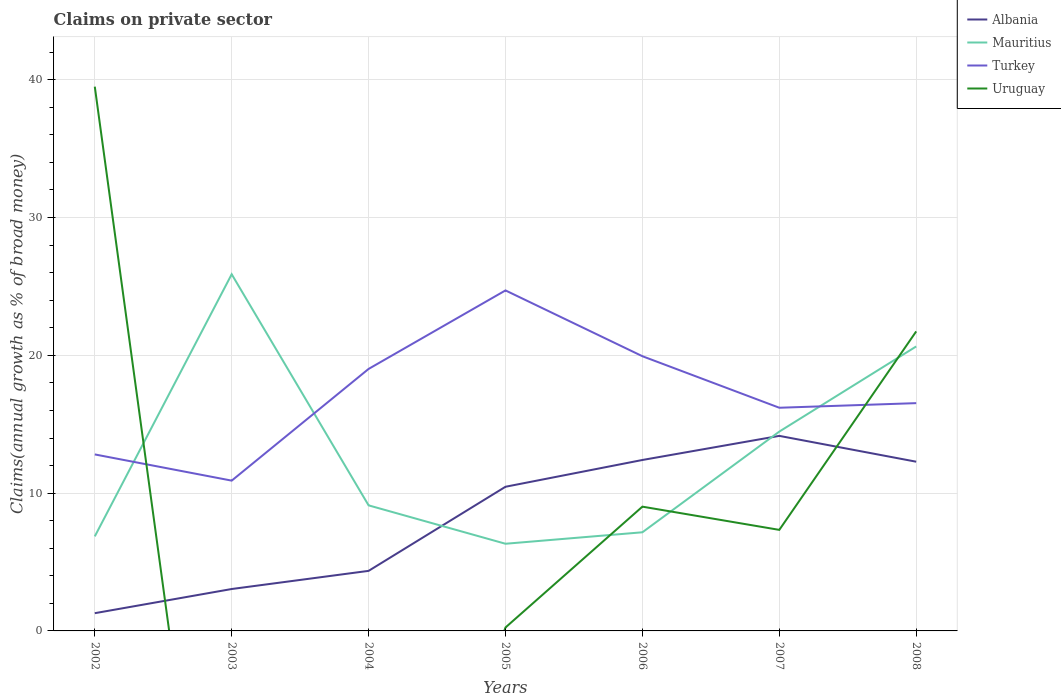How many different coloured lines are there?
Keep it short and to the point. 4. Does the line corresponding to Turkey intersect with the line corresponding to Mauritius?
Your response must be concise. Yes. Across all years, what is the maximum percentage of broad money claimed on private sector in Albania?
Your response must be concise. 1.29. What is the total percentage of broad money claimed on private sector in Mauritius in the graph?
Your response must be concise. -8.14. What is the difference between the highest and the second highest percentage of broad money claimed on private sector in Uruguay?
Keep it short and to the point. 39.5. What is the difference between the highest and the lowest percentage of broad money claimed on private sector in Uruguay?
Provide a short and direct response. 2. Is the percentage of broad money claimed on private sector in Albania strictly greater than the percentage of broad money claimed on private sector in Mauritius over the years?
Make the answer very short. No. Are the values on the major ticks of Y-axis written in scientific E-notation?
Offer a very short reply. No. Does the graph contain any zero values?
Make the answer very short. Yes. How many legend labels are there?
Your response must be concise. 4. What is the title of the graph?
Your answer should be very brief. Claims on private sector. Does "Curacao" appear as one of the legend labels in the graph?
Ensure brevity in your answer.  No. What is the label or title of the Y-axis?
Offer a very short reply. Claims(annual growth as % of broad money). What is the Claims(annual growth as % of broad money) in Albania in 2002?
Ensure brevity in your answer.  1.29. What is the Claims(annual growth as % of broad money) of Mauritius in 2002?
Provide a succinct answer. 6.86. What is the Claims(annual growth as % of broad money) of Turkey in 2002?
Your response must be concise. 12.81. What is the Claims(annual growth as % of broad money) of Uruguay in 2002?
Your answer should be very brief. 39.5. What is the Claims(annual growth as % of broad money) of Albania in 2003?
Your response must be concise. 3.04. What is the Claims(annual growth as % of broad money) of Mauritius in 2003?
Ensure brevity in your answer.  25.88. What is the Claims(annual growth as % of broad money) in Turkey in 2003?
Your response must be concise. 10.91. What is the Claims(annual growth as % of broad money) of Albania in 2004?
Provide a short and direct response. 4.36. What is the Claims(annual growth as % of broad money) of Mauritius in 2004?
Give a very brief answer. 9.11. What is the Claims(annual growth as % of broad money) in Turkey in 2004?
Ensure brevity in your answer.  19.01. What is the Claims(annual growth as % of broad money) of Uruguay in 2004?
Your answer should be very brief. 0. What is the Claims(annual growth as % of broad money) in Albania in 2005?
Your answer should be very brief. 10.46. What is the Claims(annual growth as % of broad money) of Mauritius in 2005?
Keep it short and to the point. 6.33. What is the Claims(annual growth as % of broad money) of Turkey in 2005?
Keep it short and to the point. 24.71. What is the Claims(annual growth as % of broad money) in Uruguay in 2005?
Give a very brief answer. 0.25. What is the Claims(annual growth as % of broad money) of Albania in 2006?
Your answer should be very brief. 12.41. What is the Claims(annual growth as % of broad money) of Mauritius in 2006?
Offer a terse response. 7.16. What is the Claims(annual growth as % of broad money) of Turkey in 2006?
Your answer should be very brief. 19.94. What is the Claims(annual growth as % of broad money) of Uruguay in 2006?
Make the answer very short. 9.02. What is the Claims(annual growth as % of broad money) in Albania in 2007?
Offer a terse response. 14.15. What is the Claims(annual growth as % of broad money) of Mauritius in 2007?
Offer a very short reply. 14.47. What is the Claims(annual growth as % of broad money) of Turkey in 2007?
Keep it short and to the point. 16.2. What is the Claims(annual growth as % of broad money) of Uruguay in 2007?
Offer a very short reply. 7.33. What is the Claims(annual growth as % of broad money) in Albania in 2008?
Provide a succinct answer. 12.28. What is the Claims(annual growth as % of broad money) of Mauritius in 2008?
Provide a short and direct response. 20.65. What is the Claims(annual growth as % of broad money) in Turkey in 2008?
Ensure brevity in your answer.  16.53. What is the Claims(annual growth as % of broad money) in Uruguay in 2008?
Offer a terse response. 21.74. Across all years, what is the maximum Claims(annual growth as % of broad money) of Albania?
Provide a short and direct response. 14.15. Across all years, what is the maximum Claims(annual growth as % of broad money) of Mauritius?
Offer a very short reply. 25.88. Across all years, what is the maximum Claims(annual growth as % of broad money) of Turkey?
Offer a very short reply. 24.71. Across all years, what is the maximum Claims(annual growth as % of broad money) of Uruguay?
Your response must be concise. 39.5. Across all years, what is the minimum Claims(annual growth as % of broad money) in Albania?
Your response must be concise. 1.29. Across all years, what is the minimum Claims(annual growth as % of broad money) in Mauritius?
Your answer should be very brief. 6.33. Across all years, what is the minimum Claims(annual growth as % of broad money) of Turkey?
Keep it short and to the point. 10.91. What is the total Claims(annual growth as % of broad money) in Albania in the graph?
Offer a terse response. 57.99. What is the total Claims(annual growth as % of broad money) in Mauritius in the graph?
Give a very brief answer. 90.45. What is the total Claims(annual growth as % of broad money) of Turkey in the graph?
Ensure brevity in your answer.  120.1. What is the total Claims(annual growth as % of broad money) of Uruguay in the graph?
Make the answer very short. 77.84. What is the difference between the Claims(annual growth as % of broad money) of Albania in 2002 and that in 2003?
Provide a short and direct response. -1.75. What is the difference between the Claims(annual growth as % of broad money) in Mauritius in 2002 and that in 2003?
Provide a succinct answer. -19.02. What is the difference between the Claims(annual growth as % of broad money) of Turkey in 2002 and that in 2003?
Provide a succinct answer. 1.9. What is the difference between the Claims(annual growth as % of broad money) in Albania in 2002 and that in 2004?
Provide a short and direct response. -3.07. What is the difference between the Claims(annual growth as % of broad money) in Mauritius in 2002 and that in 2004?
Your answer should be very brief. -2.25. What is the difference between the Claims(annual growth as % of broad money) in Turkey in 2002 and that in 2004?
Your response must be concise. -6.2. What is the difference between the Claims(annual growth as % of broad money) in Albania in 2002 and that in 2005?
Provide a succinct answer. -9.18. What is the difference between the Claims(annual growth as % of broad money) of Mauritius in 2002 and that in 2005?
Make the answer very short. 0.53. What is the difference between the Claims(annual growth as % of broad money) in Turkey in 2002 and that in 2005?
Give a very brief answer. -11.9. What is the difference between the Claims(annual growth as % of broad money) in Uruguay in 2002 and that in 2005?
Ensure brevity in your answer.  39.25. What is the difference between the Claims(annual growth as % of broad money) of Albania in 2002 and that in 2006?
Your answer should be compact. -11.12. What is the difference between the Claims(annual growth as % of broad money) in Mauritius in 2002 and that in 2006?
Provide a succinct answer. -0.3. What is the difference between the Claims(annual growth as % of broad money) in Turkey in 2002 and that in 2006?
Your response must be concise. -7.13. What is the difference between the Claims(annual growth as % of broad money) of Uruguay in 2002 and that in 2006?
Offer a very short reply. 30.48. What is the difference between the Claims(annual growth as % of broad money) of Albania in 2002 and that in 2007?
Provide a succinct answer. -12.87. What is the difference between the Claims(annual growth as % of broad money) of Mauritius in 2002 and that in 2007?
Provide a succinct answer. -7.61. What is the difference between the Claims(annual growth as % of broad money) in Turkey in 2002 and that in 2007?
Provide a short and direct response. -3.39. What is the difference between the Claims(annual growth as % of broad money) of Uruguay in 2002 and that in 2007?
Make the answer very short. 32.16. What is the difference between the Claims(annual growth as % of broad money) in Albania in 2002 and that in 2008?
Provide a succinct answer. -10.99. What is the difference between the Claims(annual growth as % of broad money) in Mauritius in 2002 and that in 2008?
Offer a very short reply. -13.78. What is the difference between the Claims(annual growth as % of broad money) of Turkey in 2002 and that in 2008?
Keep it short and to the point. -3.72. What is the difference between the Claims(annual growth as % of broad money) of Uruguay in 2002 and that in 2008?
Your answer should be very brief. 17.76. What is the difference between the Claims(annual growth as % of broad money) in Albania in 2003 and that in 2004?
Ensure brevity in your answer.  -1.32. What is the difference between the Claims(annual growth as % of broad money) of Mauritius in 2003 and that in 2004?
Your answer should be very brief. 16.77. What is the difference between the Claims(annual growth as % of broad money) in Turkey in 2003 and that in 2004?
Make the answer very short. -8.11. What is the difference between the Claims(annual growth as % of broad money) in Albania in 2003 and that in 2005?
Ensure brevity in your answer.  -7.42. What is the difference between the Claims(annual growth as % of broad money) of Mauritius in 2003 and that in 2005?
Make the answer very short. 19.56. What is the difference between the Claims(annual growth as % of broad money) of Turkey in 2003 and that in 2005?
Your answer should be compact. -13.8. What is the difference between the Claims(annual growth as % of broad money) of Albania in 2003 and that in 2006?
Make the answer very short. -9.36. What is the difference between the Claims(annual growth as % of broad money) of Mauritius in 2003 and that in 2006?
Your answer should be very brief. 18.73. What is the difference between the Claims(annual growth as % of broad money) in Turkey in 2003 and that in 2006?
Provide a succinct answer. -9.03. What is the difference between the Claims(annual growth as % of broad money) in Albania in 2003 and that in 2007?
Your answer should be compact. -11.11. What is the difference between the Claims(annual growth as % of broad money) in Mauritius in 2003 and that in 2007?
Your answer should be compact. 11.42. What is the difference between the Claims(annual growth as % of broad money) of Turkey in 2003 and that in 2007?
Your answer should be very brief. -5.29. What is the difference between the Claims(annual growth as % of broad money) in Albania in 2003 and that in 2008?
Keep it short and to the point. -9.24. What is the difference between the Claims(annual growth as % of broad money) of Mauritius in 2003 and that in 2008?
Keep it short and to the point. 5.24. What is the difference between the Claims(annual growth as % of broad money) in Turkey in 2003 and that in 2008?
Your answer should be compact. -5.62. What is the difference between the Claims(annual growth as % of broad money) in Albania in 2004 and that in 2005?
Offer a terse response. -6.1. What is the difference between the Claims(annual growth as % of broad money) of Mauritius in 2004 and that in 2005?
Keep it short and to the point. 2.79. What is the difference between the Claims(annual growth as % of broad money) in Turkey in 2004 and that in 2005?
Give a very brief answer. -5.7. What is the difference between the Claims(annual growth as % of broad money) of Albania in 2004 and that in 2006?
Provide a short and direct response. -8.05. What is the difference between the Claims(annual growth as % of broad money) of Mauritius in 2004 and that in 2006?
Your answer should be very brief. 1.95. What is the difference between the Claims(annual growth as % of broad money) of Turkey in 2004 and that in 2006?
Offer a terse response. -0.92. What is the difference between the Claims(annual growth as % of broad money) of Albania in 2004 and that in 2007?
Provide a short and direct response. -9.8. What is the difference between the Claims(annual growth as % of broad money) of Mauritius in 2004 and that in 2007?
Keep it short and to the point. -5.35. What is the difference between the Claims(annual growth as % of broad money) of Turkey in 2004 and that in 2007?
Your response must be concise. 2.82. What is the difference between the Claims(annual growth as % of broad money) in Albania in 2004 and that in 2008?
Ensure brevity in your answer.  -7.92. What is the difference between the Claims(annual growth as % of broad money) in Mauritius in 2004 and that in 2008?
Ensure brevity in your answer.  -11.53. What is the difference between the Claims(annual growth as % of broad money) of Turkey in 2004 and that in 2008?
Provide a succinct answer. 2.48. What is the difference between the Claims(annual growth as % of broad money) of Albania in 2005 and that in 2006?
Offer a terse response. -1.94. What is the difference between the Claims(annual growth as % of broad money) in Mauritius in 2005 and that in 2006?
Ensure brevity in your answer.  -0.83. What is the difference between the Claims(annual growth as % of broad money) of Turkey in 2005 and that in 2006?
Keep it short and to the point. 4.78. What is the difference between the Claims(annual growth as % of broad money) in Uruguay in 2005 and that in 2006?
Provide a short and direct response. -8.77. What is the difference between the Claims(annual growth as % of broad money) in Albania in 2005 and that in 2007?
Keep it short and to the point. -3.69. What is the difference between the Claims(annual growth as % of broad money) in Mauritius in 2005 and that in 2007?
Offer a very short reply. -8.14. What is the difference between the Claims(annual growth as % of broad money) in Turkey in 2005 and that in 2007?
Ensure brevity in your answer.  8.51. What is the difference between the Claims(annual growth as % of broad money) in Uruguay in 2005 and that in 2007?
Keep it short and to the point. -7.08. What is the difference between the Claims(annual growth as % of broad money) in Albania in 2005 and that in 2008?
Provide a short and direct response. -1.82. What is the difference between the Claims(annual growth as % of broad money) of Mauritius in 2005 and that in 2008?
Offer a terse response. -14.32. What is the difference between the Claims(annual growth as % of broad money) in Turkey in 2005 and that in 2008?
Provide a short and direct response. 8.18. What is the difference between the Claims(annual growth as % of broad money) of Uruguay in 2005 and that in 2008?
Provide a short and direct response. -21.49. What is the difference between the Claims(annual growth as % of broad money) in Albania in 2006 and that in 2007?
Provide a short and direct response. -1.75. What is the difference between the Claims(annual growth as % of broad money) in Mauritius in 2006 and that in 2007?
Offer a terse response. -7.31. What is the difference between the Claims(annual growth as % of broad money) of Turkey in 2006 and that in 2007?
Provide a succinct answer. 3.74. What is the difference between the Claims(annual growth as % of broad money) of Uruguay in 2006 and that in 2007?
Make the answer very short. 1.68. What is the difference between the Claims(annual growth as % of broad money) in Albania in 2006 and that in 2008?
Offer a very short reply. 0.12. What is the difference between the Claims(annual growth as % of broad money) in Mauritius in 2006 and that in 2008?
Offer a very short reply. -13.49. What is the difference between the Claims(annual growth as % of broad money) in Turkey in 2006 and that in 2008?
Give a very brief answer. 3.4. What is the difference between the Claims(annual growth as % of broad money) in Uruguay in 2006 and that in 2008?
Give a very brief answer. -12.72. What is the difference between the Claims(annual growth as % of broad money) of Albania in 2007 and that in 2008?
Give a very brief answer. 1.87. What is the difference between the Claims(annual growth as % of broad money) in Mauritius in 2007 and that in 2008?
Your response must be concise. -6.18. What is the difference between the Claims(annual growth as % of broad money) of Turkey in 2007 and that in 2008?
Provide a succinct answer. -0.33. What is the difference between the Claims(annual growth as % of broad money) in Uruguay in 2007 and that in 2008?
Keep it short and to the point. -14.4. What is the difference between the Claims(annual growth as % of broad money) in Albania in 2002 and the Claims(annual growth as % of broad money) in Mauritius in 2003?
Your answer should be very brief. -24.6. What is the difference between the Claims(annual growth as % of broad money) in Albania in 2002 and the Claims(annual growth as % of broad money) in Turkey in 2003?
Make the answer very short. -9.62. What is the difference between the Claims(annual growth as % of broad money) in Mauritius in 2002 and the Claims(annual growth as % of broad money) in Turkey in 2003?
Provide a short and direct response. -4.05. What is the difference between the Claims(annual growth as % of broad money) of Albania in 2002 and the Claims(annual growth as % of broad money) of Mauritius in 2004?
Your answer should be compact. -7.83. What is the difference between the Claims(annual growth as % of broad money) in Albania in 2002 and the Claims(annual growth as % of broad money) in Turkey in 2004?
Provide a succinct answer. -17.73. What is the difference between the Claims(annual growth as % of broad money) in Mauritius in 2002 and the Claims(annual growth as % of broad money) in Turkey in 2004?
Offer a terse response. -12.15. What is the difference between the Claims(annual growth as % of broad money) in Albania in 2002 and the Claims(annual growth as % of broad money) in Mauritius in 2005?
Provide a succinct answer. -5.04. What is the difference between the Claims(annual growth as % of broad money) of Albania in 2002 and the Claims(annual growth as % of broad money) of Turkey in 2005?
Provide a short and direct response. -23.42. What is the difference between the Claims(annual growth as % of broad money) of Albania in 2002 and the Claims(annual growth as % of broad money) of Uruguay in 2005?
Your response must be concise. 1.04. What is the difference between the Claims(annual growth as % of broad money) of Mauritius in 2002 and the Claims(annual growth as % of broad money) of Turkey in 2005?
Make the answer very short. -17.85. What is the difference between the Claims(annual growth as % of broad money) of Mauritius in 2002 and the Claims(annual growth as % of broad money) of Uruguay in 2005?
Your answer should be compact. 6.61. What is the difference between the Claims(annual growth as % of broad money) of Turkey in 2002 and the Claims(annual growth as % of broad money) of Uruguay in 2005?
Keep it short and to the point. 12.56. What is the difference between the Claims(annual growth as % of broad money) of Albania in 2002 and the Claims(annual growth as % of broad money) of Mauritius in 2006?
Keep it short and to the point. -5.87. What is the difference between the Claims(annual growth as % of broad money) of Albania in 2002 and the Claims(annual growth as % of broad money) of Turkey in 2006?
Provide a short and direct response. -18.65. What is the difference between the Claims(annual growth as % of broad money) in Albania in 2002 and the Claims(annual growth as % of broad money) in Uruguay in 2006?
Provide a short and direct response. -7.73. What is the difference between the Claims(annual growth as % of broad money) of Mauritius in 2002 and the Claims(annual growth as % of broad money) of Turkey in 2006?
Your answer should be very brief. -13.08. What is the difference between the Claims(annual growth as % of broad money) in Mauritius in 2002 and the Claims(annual growth as % of broad money) in Uruguay in 2006?
Ensure brevity in your answer.  -2.16. What is the difference between the Claims(annual growth as % of broad money) of Turkey in 2002 and the Claims(annual growth as % of broad money) of Uruguay in 2006?
Make the answer very short. 3.79. What is the difference between the Claims(annual growth as % of broad money) of Albania in 2002 and the Claims(annual growth as % of broad money) of Mauritius in 2007?
Ensure brevity in your answer.  -13.18. What is the difference between the Claims(annual growth as % of broad money) of Albania in 2002 and the Claims(annual growth as % of broad money) of Turkey in 2007?
Make the answer very short. -14.91. What is the difference between the Claims(annual growth as % of broad money) in Albania in 2002 and the Claims(annual growth as % of broad money) in Uruguay in 2007?
Offer a very short reply. -6.05. What is the difference between the Claims(annual growth as % of broad money) in Mauritius in 2002 and the Claims(annual growth as % of broad money) in Turkey in 2007?
Offer a terse response. -9.34. What is the difference between the Claims(annual growth as % of broad money) in Mauritius in 2002 and the Claims(annual growth as % of broad money) in Uruguay in 2007?
Make the answer very short. -0.47. What is the difference between the Claims(annual growth as % of broad money) of Turkey in 2002 and the Claims(annual growth as % of broad money) of Uruguay in 2007?
Offer a very short reply. 5.48. What is the difference between the Claims(annual growth as % of broad money) of Albania in 2002 and the Claims(annual growth as % of broad money) of Mauritius in 2008?
Keep it short and to the point. -19.36. What is the difference between the Claims(annual growth as % of broad money) in Albania in 2002 and the Claims(annual growth as % of broad money) in Turkey in 2008?
Give a very brief answer. -15.24. What is the difference between the Claims(annual growth as % of broad money) of Albania in 2002 and the Claims(annual growth as % of broad money) of Uruguay in 2008?
Your answer should be very brief. -20.45. What is the difference between the Claims(annual growth as % of broad money) of Mauritius in 2002 and the Claims(annual growth as % of broad money) of Turkey in 2008?
Make the answer very short. -9.67. What is the difference between the Claims(annual growth as % of broad money) of Mauritius in 2002 and the Claims(annual growth as % of broad money) of Uruguay in 2008?
Ensure brevity in your answer.  -14.88. What is the difference between the Claims(annual growth as % of broad money) in Turkey in 2002 and the Claims(annual growth as % of broad money) in Uruguay in 2008?
Provide a succinct answer. -8.93. What is the difference between the Claims(annual growth as % of broad money) in Albania in 2003 and the Claims(annual growth as % of broad money) in Mauritius in 2004?
Give a very brief answer. -6.07. What is the difference between the Claims(annual growth as % of broad money) of Albania in 2003 and the Claims(annual growth as % of broad money) of Turkey in 2004?
Offer a very short reply. -15.97. What is the difference between the Claims(annual growth as % of broad money) of Mauritius in 2003 and the Claims(annual growth as % of broad money) of Turkey in 2004?
Make the answer very short. 6.87. What is the difference between the Claims(annual growth as % of broad money) in Albania in 2003 and the Claims(annual growth as % of broad money) in Mauritius in 2005?
Ensure brevity in your answer.  -3.28. What is the difference between the Claims(annual growth as % of broad money) in Albania in 2003 and the Claims(annual growth as % of broad money) in Turkey in 2005?
Provide a succinct answer. -21.67. What is the difference between the Claims(annual growth as % of broad money) of Albania in 2003 and the Claims(annual growth as % of broad money) of Uruguay in 2005?
Give a very brief answer. 2.79. What is the difference between the Claims(annual growth as % of broad money) of Mauritius in 2003 and the Claims(annual growth as % of broad money) of Turkey in 2005?
Your response must be concise. 1.17. What is the difference between the Claims(annual growth as % of broad money) of Mauritius in 2003 and the Claims(annual growth as % of broad money) of Uruguay in 2005?
Provide a short and direct response. 25.64. What is the difference between the Claims(annual growth as % of broad money) of Turkey in 2003 and the Claims(annual growth as % of broad money) of Uruguay in 2005?
Offer a terse response. 10.66. What is the difference between the Claims(annual growth as % of broad money) of Albania in 2003 and the Claims(annual growth as % of broad money) of Mauritius in 2006?
Offer a very short reply. -4.12. What is the difference between the Claims(annual growth as % of broad money) in Albania in 2003 and the Claims(annual growth as % of broad money) in Turkey in 2006?
Keep it short and to the point. -16.89. What is the difference between the Claims(annual growth as % of broad money) in Albania in 2003 and the Claims(annual growth as % of broad money) in Uruguay in 2006?
Your answer should be compact. -5.98. What is the difference between the Claims(annual growth as % of broad money) in Mauritius in 2003 and the Claims(annual growth as % of broad money) in Turkey in 2006?
Your response must be concise. 5.95. What is the difference between the Claims(annual growth as % of broad money) of Mauritius in 2003 and the Claims(annual growth as % of broad money) of Uruguay in 2006?
Ensure brevity in your answer.  16.87. What is the difference between the Claims(annual growth as % of broad money) in Turkey in 2003 and the Claims(annual growth as % of broad money) in Uruguay in 2006?
Keep it short and to the point. 1.89. What is the difference between the Claims(annual growth as % of broad money) of Albania in 2003 and the Claims(annual growth as % of broad money) of Mauritius in 2007?
Your answer should be compact. -11.42. What is the difference between the Claims(annual growth as % of broad money) in Albania in 2003 and the Claims(annual growth as % of broad money) in Turkey in 2007?
Give a very brief answer. -13.16. What is the difference between the Claims(annual growth as % of broad money) in Albania in 2003 and the Claims(annual growth as % of broad money) in Uruguay in 2007?
Give a very brief answer. -4.29. What is the difference between the Claims(annual growth as % of broad money) of Mauritius in 2003 and the Claims(annual growth as % of broad money) of Turkey in 2007?
Provide a succinct answer. 9.69. What is the difference between the Claims(annual growth as % of broad money) in Mauritius in 2003 and the Claims(annual growth as % of broad money) in Uruguay in 2007?
Provide a succinct answer. 18.55. What is the difference between the Claims(annual growth as % of broad money) in Turkey in 2003 and the Claims(annual growth as % of broad money) in Uruguay in 2007?
Offer a terse response. 3.57. What is the difference between the Claims(annual growth as % of broad money) of Albania in 2003 and the Claims(annual growth as % of broad money) of Mauritius in 2008?
Give a very brief answer. -17.6. What is the difference between the Claims(annual growth as % of broad money) of Albania in 2003 and the Claims(annual growth as % of broad money) of Turkey in 2008?
Make the answer very short. -13.49. What is the difference between the Claims(annual growth as % of broad money) in Albania in 2003 and the Claims(annual growth as % of broad money) in Uruguay in 2008?
Provide a succinct answer. -18.7. What is the difference between the Claims(annual growth as % of broad money) of Mauritius in 2003 and the Claims(annual growth as % of broad money) of Turkey in 2008?
Provide a short and direct response. 9.35. What is the difference between the Claims(annual growth as % of broad money) in Mauritius in 2003 and the Claims(annual growth as % of broad money) in Uruguay in 2008?
Keep it short and to the point. 4.15. What is the difference between the Claims(annual growth as % of broad money) of Turkey in 2003 and the Claims(annual growth as % of broad money) of Uruguay in 2008?
Ensure brevity in your answer.  -10.83. What is the difference between the Claims(annual growth as % of broad money) in Albania in 2004 and the Claims(annual growth as % of broad money) in Mauritius in 2005?
Give a very brief answer. -1.97. What is the difference between the Claims(annual growth as % of broad money) in Albania in 2004 and the Claims(annual growth as % of broad money) in Turkey in 2005?
Give a very brief answer. -20.35. What is the difference between the Claims(annual growth as % of broad money) of Albania in 2004 and the Claims(annual growth as % of broad money) of Uruguay in 2005?
Provide a short and direct response. 4.11. What is the difference between the Claims(annual growth as % of broad money) in Mauritius in 2004 and the Claims(annual growth as % of broad money) in Turkey in 2005?
Make the answer very short. -15.6. What is the difference between the Claims(annual growth as % of broad money) in Mauritius in 2004 and the Claims(annual growth as % of broad money) in Uruguay in 2005?
Keep it short and to the point. 8.86. What is the difference between the Claims(annual growth as % of broad money) of Turkey in 2004 and the Claims(annual growth as % of broad money) of Uruguay in 2005?
Your answer should be very brief. 18.76. What is the difference between the Claims(annual growth as % of broad money) in Albania in 2004 and the Claims(annual growth as % of broad money) in Mauritius in 2006?
Keep it short and to the point. -2.8. What is the difference between the Claims(annual growth as % of broad money) of Albania in 2004 and the Claims(annual growth as % of broad money) of Turkey in 2006?
Ensure brevity in your answer.  -15.58. What is the difference between the Claims(annual growth as % of broad money) of Albania in 2004 and the Claims(annual growth as % of broad money) of Uruguay in 2006?
Your response must be concise. -4.66. What is the difference between the Claims(annual growth as % of broad money) in Mauritius in 2004 and the Claims(annual growth as % of broad money) in Turkey in 2006?
Ensure brevity in your answer.  -10.82. What is the difference between the Claims(annual growth as % of broad money) of Mauritius in 2004 and the Claims(annual growth as % of broad money) of Uruguay in 2006?
Give a very brief answer. 0.09. What is the difference between the Claims(annual growth as % of broad money) in Turkey in 2004 and the Claims(annual growth as % of broad money) in Uruguay in 2006?
Provide a succinct answer. 10. What is the difference between the Claims(annual growth as % of broad money) in Albania in 2004 and the Claims(annual growth as % of broad money) in Mauritius in 2007?
Make the answer very short. -10.11. What is the difference between the Claims(annual growth as % of broad money) of Albania in 2004 and the Claims(annual growth as % of broad money) of Turkey in 2007?
Your answer should be compact. -11.84. What is the difference between the Claims(annual growth as % of broad money) of Albania in 2004 and the Claims(annual growth as % of broad money) of Uruguay in 2007?
Offer a very short reply. -2.97. What is the difference between the Claims(annual growth as % of broad money) in Mauritius in 2004 and the Claims(annual growth as % of broad money) in Turkey in 2007?
Your answer should be compact. -7.08. What is the difference between the Claims(annual growth as % of broad money) of Mauritius in 2004 and the Claims(annual growth as % of broad money) of Uruguay in 2007?
Your answer should be very brief. 1.78. What is the difference between the Claims(annual growth as % of broad money) of Turkey in 2004 and the Claims(annual growth as % of broad money) of Uruguay in 2007?
Keep it short and to the point. 11.68. What is the difference between the Claims(annual growth as % of broad money) of Albania in 2004 and the Claims(annual growth as % of broad money) of Mauritius in 2008?
Give a very brief answer. -16.29. What is the difference between the Claims(annual growth as % of broad money) in Albania in 2004 and the Claims(annual growth as % of broad money) in Turkey in 2008?
Offer a very short reply. -12.17. What is the difference between the Claims(annual growth as % of broad money) of Albania in 2004 and the Claims(annual growth as % of broad money) of Uruguay in 2008?
Ensure brevity in your answer.  -17.38. What is the difference between the Claims(annual growth as % of broad money) of Mauritius in 2004 and the Claims(annual growth as % of broad money) of Turkey in 2008?
Your answer should be very brief. -7.42. What is the difference between the Claims(annual growth as % of broad money) in Mauritius in 2004 and the Claims(annual growth as % of broad money) in Uruguay in 2008?
Offer a terse response. -12.62. What is the difference between the Claims(annual growth as % of broad money) of Turkey in 2004 and the Claims(annual growth as % of broad money) of Uruguay in 2008?
Offer a very short reply. -2.72. What is the difference between the Claims(annual growth as % of broad money) in Albania in 2005 and the Claims(annual growth as % of broad money) in Mauritius in 2006?
Provide a short and direct response. 3.3. What is the difference between the Claims(annual growth as % of broad money) in Albania in 2005 and the Claims(annual growth as % of broad money) in Turkey in 2006?
Provide a short and direct response. -9.47. What is the difference between the Claims(annual growth as % of broad money) of Albania in 2005 and the Claims(annual growth as % of broad money) of Uruguay in 2006?
Provide a short and direct response. 1.44. What is the difference between the Claims(annual growth as % of broad money) in Mauritius in 2005 and the Claims(annual growth as % of broad money) in Turkey in 2006?
Provide a short and direct response. -13.61. What is the difference between the Claims(annual growth as % of broad money) in Mauritius in 2005 and the Claims(annual growth as % of broad money) in Uruguay in 2006?
Your response must be concise. -2.69. What is the difference between the Claims(annual growth as % of broad money) of Turkey in 2005 and the Claims(annual growth as % of broad money) of Uruguay in 2006?
Give a very brief answer. 15.69. What is the difference between the Claims(annual growth as % of broad money) of Albania in 2005 and the Claims(annual growth as % of broad money) of Mauritius in 2007?
Ensure brevity in your answer.  -4. What is the difference between the Claims(annual growth as % of broad money) in Albania in 2005 and the Claims(annual growth as % of broad money) in Turkey in 2007?
Give a very brief answer. -5.73. What is the difference between the Claims(annual growth as % of broad money) in Albania in 2005 and the Claims(annual growth as % of broad money) in Uruguay in 2007?
Ensure brevity in your answer.  3.13. What is the difference between the Claims(annual growth as % of broad money) of Mauritius in 2005 and the Claims(annual growth as % of broad money) of Turkey in 2007?
Your answer should be very brief. -9.87. What is the difference between the Claims(annual growth as % of broad money) in Mauritius in 2005 and the Claims(annual growth as % of broad money) in Uruguay in 2007?
Make the answer very short. -1.01. What is the difference between the Claims(annual growth as % of broad money) in Turkey in 2005 and the Claims(annual growth as % of broad money) in Uruguay in 2007?
Your response must be concise. 17.38. What is the difference between the Claims(annual growth as % of broad money) of Albania in 2005 and the Claims(annual growth as % of broad money) of Mauritius in 2008?
Ensure brevity in your answer.  -10.18. What is the difference between the Claims(annual growth as % of broad money) of Albania in 2005 and the Claims(annual growth as % of broad money) of Turkey in 2008?
Provide a succinct answer. -6.07. What is the difference between the Claims(annual growth as % of broad money) of Albania in 2005 and the Claims(annual growth as % of broad money) of Uruguay in 2008?
Your answer should be compact. -11.27. What is the difference between the Claims(annual growth as % of broad money) of Mauritius in 2005 and the Claims(annual growth as % of broad money) of Turkey in 2008?
Provide a succinct answer. -10.21. What is the difference between the Claims(annual growth as % of broad money) of Mauritius in 2005 and the Claims(annual growth as % of broad money) of Uruguay in 2008?
Ensure brevity in your answer.  -15.41. What is the difference between the Claims(annual growth as % of broad money) in Turkey in 2005 and the Claims(annual growth as % of broad money) in Uruguay in 2008?
Ensure brevity in your answer.  2.97. What is the difference between the Claims(annual growth as % of broad money) of Albania in 2006 and the Claims(annual growth as % of broad money) of Mauritius in 2007?
Provide a short and direct response. -2.06. What is the difference between the Claims(annual growth as % of broad money) in Albania in 2006 and the Claims(annual growth as % of broad money) in Turkey in 2007?
Offer a very short reply. -3.79. What is the difference between the Claims(annual growth as % of broad money) in Albania in 2006 and the Claims(annual growth as % of broad money) in Uruguay in 2007?
Give a very brief answer. 5.07. What is the difference between the Claims(annual growth as % of broad money) of Mauritius in 2006 and the Claims(annual growth as % of broad money) of Turkey in 2007?
Offer a terse response. -9.04. What is the difference between the Claims(annual growth as % of broad money) of Mauritius in 2006 and the Claims(annual growth as % of broad money) of Uruguay in 2007?
Provide a short and direct response. -0.17. What is the difference between the Claims(annual growth as % of broad money) in Turkey in 2006 and the Claims(annual growth as % of broad money) in Uruguay in 2007?
Provide a short and direct response. 12.6. What is the difference between the Claims(annual growth as % of broad money) of Albania in 2006 and the Claims(annual growth as % of broad money) of Mauritius in 2008?
Your answer should be very brief. -8.24. What is the difference between the Claims(annual growth as % of broad money) of Albania in 2006 and the Claims(annual growth as % of broad money) of Turkey in 2008?
Your answer should be compact. -4.13. What is the difference between the Claims(annual growth as % of broad money) of Albania in 2006 and the Claims(annual growth as % of broad money) of Uruguay in 2008?
Offer a very short reply. -9.33. What is the difference between the Claims(annual growth as % of broad money) of Mauritius in 2006 and the Claims(annual growth as % of broad money) of Turkey in 2008?
Provide a succinct answer. -9.37. What is the difference between the Claims(annual growth as % of broad money) of Mauritius in 2006 and the Claims(annual growth as % of broad money) of Uruguay in 2008?
Offer a terse response. -14.58. What is the difference between the Claims(annual growth as % of broad money) of Turkey in 2006 and the Claims(annual growth as % of broad money) of Uruguay in 2008?
Provide a short and direct response. -1.8. What is the difference between the Claims(annual growth as % of broad money) in Albania in 2007 and the Claims(annual growth as % of broad money) in Mauritius in 2008?
Keep it short and to the point. -6.49. What is the difference between the Claims(annual growth as % of broad money) of Albania in 2007 and the Claims(annual growth as % of broad money) of Turkey in 2008?
Give a very brief answer. -2.38. What is the difference between the Claims(annual growth as % of broad money) of Albania in 2007 and the Claims(annual growth as % of broad money) of Uruguay in 2008?
Your answer should be compact. -7.58. What is the difference between the Claims(annual growth as % of broad money) of Mauritius in 2007 and the Claims(annual growth as % of broad money) of Turkey in 2008?
Ensure brevity in your answer.  -2.06. What is the difference between the Claims(annual growth as % of broad money) of Mauritius in 2007 and the Claims(annual growth as % of broad money) of Uruguay in 2008?
Your answer should be compact. -7.27. What is the difference between the Claims(annual growth as % of broad money) in Turkey in 2007 and the Claims(annual growth as % of broad money) in Uruguay in 2008?
Provide a succinct answer. -5.54. What is the average Claims(annual growth as % of broad money) of Albania per year?
Provide a succinct answer. 8.28. What is the average Claims(annual growth as % of broad money) in Mauritius per year?
Provide a succinct answer. 12.92. What is the average Claims(annual growth as % of broad money) of Turkey per year?
Provide a short and direct response. 17.16. What is the average Claims(annual growth as % of broad money) in Uruguay per year?
Keep it short and to the point. 11.12. In the year 2002, what is the difference between the Claims(annual growth as % of broad money) of Albania and Claims(annual growth as % of broad money) of Mauritius?
Give a very brief answer. -5.57. In the year 2002, what is the difference between the Claims(annual growth as % of broad money) of Albania and Claims(annual growth as % of broad money) of Turkey?
Offer a very short reply. -11.52. In the year 2002, what is the difference between the Claims(annual growth as % of broad money) in Albania and Claims(annual growth as % of broad money) in Uruguay?
Offer a very short reply. -38.21. In the year 2002, what is the difference between the Claims(annual growth as % of broad money) in Mauritius and Claims(annual growth as % of broad money) in Turkey?
Your answer should be very brief. -5.95. In the year 2002, what is the difference between the Claims(annual growth as % of broad money) of Mauritius and Claims(annual growth as % of broad money) of Uruguay?
Give a very brief answer. -32.64. In the year 2002, what is the difference between the Claims(annual growth as % of broad money) in Turkey and Claims(annual growth as % of broad money) in Uruguay?
Offer a very short reply. -26.69. In the year 2003, what is the difference between the Claims(annual growth as % of broad money) of Albania and Claims(annual growth as % of broad money) of Mauritius?
Give a very brief answer. -22.84. In the year 2003, what is the difference between the Claims(annual growth as % of broad money) in Albania and Claims(annual growth as % of broad money) in Turkey?
Make the answer very short. -7.87. In the year 2003, what is the difference between the Claims(annual growth as % of broad money) in Mauritius and Claims(annual growth as % of broad money) in Turkey?
Give a very brief answer. 14.98. In the year 2004, what is the difference between the Claims(annual growth as % of broad money) of Albania and Claims(annual growth as % of broad money) of Mauritius?
Provide a succinct answer. -4.75. In the year 2004, what is the difference between the Claims(annual growth as % of broad money) of Albania and Claims(annual growth as % of broad money) of Turkey?
Offer a very short reply. -14.65. In the year 2004, what is the difference between the Claims(annual growth as % of broad money) of Mauritius and Claims(annual growth as % of broad money) of Turkey?
Keep it short and to the point. -9.9. In the year 2005, what is the difference between the Claims(annual growth as % of broad money) in Albania and Claims(annual growth as % of broad money) in Mauritius?
Your answer should be compact. 4.14. In the year 2005, what is the difference between the Claims(annual growth as % of broad money) of Albania and Claims(annual growth as % of broad money) of Turkey?
Provide a short and direct response. -14.25. In the year 2005, what is the difference between the Claims(annual growth as % of broad money) in Albania and Claims(annual growth as % of broad money) in Uruguay?
Offer a very short reply. 10.21. In the year 2005, what is the difference between the Claims(annual growth as % of broad money) in Mauritius and Claims(annual growth as % of broad money) in Turkey?
Make the answer very short. -18.39. In the year 2005, what is the difference between the Claims(annual growth as % of broad money) of Mauritius and Claims(annual growth as % of broad money) of Uruguay?
Your answer should be very brief. 6.08. In the year 2005, what is the difference between the Claims(annual growth as % of broad money) of Turkey and Claims(annual growth as % of broad money) of Uruguay?
Ensure brevity in your answer.  24.46. In the year 2006, what is the difference between the Claims(annual growth as % of broad money) of Albania and Claims(annual growth as % of broad money) of Mauritius?
Provide a succinct answer. 5.25. In the year 2006, what is the difference between the Claims(annual growth as % of broad money) of Albania and Claims(annual growth as % of broad money) of Turkey?
Offer a terse response. -7.53. In the year 2006, what is the difference between the Claims(annual growth as % of broad money) in Albania and Claims(annual growth as % of broad money) in Uruguay?
Give a very brief answer. 3.39. In the year 2006, what is the difference between the Claims(annual growth as % of broad money) of Mauritius and Claims(annual growth as % of broad money) of Turkey?
Keep it short and to the point. -12.78. In the year 2006, what is the difference between the Claims(annual growth as % of broad money) of Mauritius and Claims(annual growth as % of broad money) of Uruguay?
Offer a terse response. -1.86. In the year 2006, what is the difference between the Claims(annual growth as % of broad money) in Turkey and Claims(annual growth as % of broad money) in Uruguay?
Ensure brevity in your answer.  10.92. In the year 2007, what is the difference between the Claims(annual growth as % of broad money) of Albania and Claims(annual growth as % of broad money) of Mauritius?
Offer a very short reply. -0.31. In the year 2007, what is the difference between the Claims(annual growth as % of broad money) of Albania and Claims(annual growth as % of broad money) of Turkey?
Provide a short and direct response. -2.04. In the year 2007, what is the difference between the Claims(annual growth as % of broad money) in Albania and Claims(annual growth as % of broad money) in Uruguay?
Provide a short and direct response. 6.82. In the year 2007, what is the difference between the Claims(annual growth as % of broad money) in Mauritius and Claims(annual growth as % of broad money) in Turkey?
Provide a short and direct response. -1.73. In the year 2007, what is the difference between the Claims(annual growth as % of broad money) in Mauritius and Claims(annual growth as % of broad money) in Uruguay?
Give a very brief answer. 7.13. In the year 2007, what is the difference between the Claims(annual growth as % of broad money) of Turkey and Claims(annual growth as % of broad money) of Uruguay?
Your answer should be very brief. 8.86. In the year 2008, what is the difference between the Claims(annual growth as % of broad money) in Albania and Claims(annual growth as % of broad money) in Mauritius?
Ensure brevity in your answer.  -8.36. In the year 2008, what is the difference between the Claims(annual growth as % of broad money) in Albania and Claims(annual growth as % of broad money) in Turkey?
Make the answer very short. -4.25. In the year 2008, what is the difference between the Claims(annual growth as % of broad money) of Albania and Claims(annual growth as % of broad money) of Uruguay?
Your answer should be very brief. -9.46. In the year 2008, what is the difference between the Claims(annual growth as % of broad money) of Mauritius and Claims(annual growth as % of broad money) of Turkey?
Keep it short and to the point. 4.11. In the year 2008, what is the difference between the Claims(annual growth as % of broad money) of Mauritius and Claims(annual growth as % of broad money) of Uruguay?
Your answer should be very brief. -1.09. In the year 2008, what is the difference between the Claims(annual growth as % of broad money) in Turkey and Claims(annual growth as % of broad money) in Uruguay?
Your answer should be very brief. -5.21. What is the ratio of the Claims(annual growth as % of broad money) of Albania in 2002 to that in 2003?
Your response must be concise. 0.42. What is the ratio of the Claims(annual growth as % of broad money) in Mauritius in 2002 to that in 2003?
Provide a short and direct response. 0.27. What is the ratio of the Claims(annual growth as % of broad money) of Turkey in 2002 to that in 2003?
Offer a terse response. 1.17. What is the ratio of the Claims(annual growth as % of broad money) of Albania in 2002 to that in 2004?
Provide a short and direct response. 0.3. What is the ratio of the Claims(annual growth as % of broad money) of Mauritius in 2002 to that in 2004?
Your answer should be very brief. 0.75. What is the ratio of the Claims(annual growth as % of broad money) in Turkey in 2002 to that in 2004?
Provide a short and direct response. 0.67. What is the ratio of the Claims(annual growth as % of broad money) of Albania in 2002 to that in 2005?
Offer a terse response. 0.12. What is the ratio of the Claims(annual growth as % of broad money) in Mauritius in 2002 to that in 2005?
Your response must be concise. 1.08. What is the ratio of the Claims(annual growth as % of broad money) in Turkey in 2002 to that in 2005?
Ensure brevity in your answer.  0.52. What is the ratio of the Claims(annual growth as % of broad money) in Uruguay in 2002 to that in 2005?
Your answer should be very brief. 158.67. What is the ratio of the Claims(annual growth as % of broad money) of Albania in 2002 to that in 2006?
Your response must be concise. 0.1. What is the ratio of the Claims(annual growth as % of broad money) of Mauritius in 2002 to that in 2006?
Offer a very short reply. 0.96. What is the ratio of the Claims(annual growth as % of broad money) of Turkey in 2002 to that in 2006?
Keep it short and to the point. 0.64. What is the ratio of the Claims(annual growth as % of broad money) of Uruguay in 2002 to that in 2006?
Your answer should be compact. 4.38. What is the ratio of the Claims(annual growth as % of broad money) in Albania in 2002 to that in 2007?
Ensure brevity in your answer.  0.09. What is the ratio of the Claims(annual growth as % of broad money) of Mauritius in 2002 to that in 2007?
Provide a short and direct response. 0.47. What is the ratio of the Claims(annual growth as % of broad money) of Turkey in 2002 to that in 2007?
Offer a terse response. 0.79. What is the ratio of the Claims(annual growth as % of broad money) in Uruguay in 2002 to that in 2007?
Your answer should be very brief. 5.39. What is the ratio of the Claims(annual growth as % of broad money) in Albania in 2002 to that in 2008?
Offer a very short reply. 0.1. What is the ratio of the Claims(annual growth as % of broad money) in Mauritius in 2002 to that in 2008?
Keep it short and to the point. 0.33. What is the ratio of the Claims(annual growth as % of broad money) of Turkey in 2002 to that in 2008?
Your response must be concise. 0.77. What is the ratio of the Claims(annual growth as % of broad money) in Uruguay in 2002 to that in 2008?
Ensure brevity in your answer.  1.82. What is the ratio of the Claims(annual growth as % of broad money) of Albania in 2003 to that in 2004?
Provide a succinct answer. 0.7. What is the ratio of the Claims(annual growth as % of broad money) in Mauritius in 2003 to that in 2004?
Ensure brevity in your answer.  2.84. What is the ratio of the Claims(annual growth as % of broad money) of Turkey in 2003 to that in 2004?
Provide a succinct answer. 0.57. What is the ratio of the Claims(annual growth as % of broad money) in Albania in 2003 to that in 2005?
Give a very brief answer. 0.29. What is the ratio of the Claims(annual growth as % of broad money) in Mauritius in 2003 to that in 2005?
Provide a succinct answer. 4.09. What is the ratio of the Claims(annual growth as % of broad money) in Turkey in 2003 to that in 2005?
Provide a short and direct response. 0.44. What is the ratio of the Claims(annual growth as % of broad money) in Albania in 2003 to that in 2006?
Provide a succinct answer. 0.25. What is the ratio of the Claims(annual growth as % of broad money) in Mauritius in 2003 to that in 2006?
Make the answer very short. 3.62. What is the ratio of the Claims(annual growth as % of broad money) in Turkey in 2003 to that in 2006?
Make the answer very short. 0.55. What is the ratio of the Claims(annual growth as % of broad money) of Albania in 2003 to that in 2007?
Provide a short and direct response. 0.21. What is the ratio of the Claims(annual growth as % of broad money) of Mauritius in 2003 to that in 2007?
Your response must be concise. 1.79. What is the ratio of the Claims(annual growth as % of broad money) of Turkey in 2003 to that in 2007?
Your response must be concise. 0.67. What is the ratio of the Claims(annual growth as % of broad money) of Albania in 2003 to that in 2008?
Make the answer very short. 0.25. What is the ratio of the Claims(annual growth as % of broad money) in Mauritius in 2003 to that in 2008?
Give a very brief answer. 1.25. What is the ratio of the Claims(annual growth as % of broad money) in Turkey in 2003 to that in 2008?
Make the answer very short. 0.66. What is the ratio of the Claims(annual growth as % of broad money) in Albania in 2004 to that in 2005?
Give a very brief answer. 0.42. What is the ratio of the Claims(annual growth as % of broad money) of Mauritius in 2004 to that in 2005?
Offer a very short reply. 1.44. What is the ratio of the Claims(annual growth as % of broad money) of Turkey in 2004 to that in 2005?
Make the answer very short. 0.77. What is the ratio of the Claims(annual growth as % of broad money) of Albania in 2004 to that in 2006?
Offer a very short reply. 0.35. What is the ratio of the Claims(annual growth as % of broad money) of Mauritius in 2004 to that in 2006?
Keep it short and to the point. 1.27. What is the ratio of the Claims(annual growth as % of broad money) in Turkey in 2004 to that in 2006?
Your response must be concise. 0.95. What is the ratio of the Claims(annual growth as % of broad money) in Albania in 2004 to that in 2007?
Provide a short and direct response. 0.31. What is the ratio of the Claims(annual growth as % of broad money) in Mauritius in 2004 to that in 2007?
Your answer should be very brief. 0.63. What is the ratio of the Claims(annual growth as % of broad money) of Turkey in 2004 to that in 2007?
Ensure brevity in your answer.  1.17. What is the ratio of the Claims(annual growth as % of broad money) of Albania in 2004 to that in 2008?
Provide a short and direct response. 0.35. What is the ratio of the Claims(annual growth as % of broad money) of Mauritius in 2004 to that in 2008?
Your answer should be very brief. 0.44. What is the ratio of the Claims(annual growth as % of broad money) in Turkey in 2004 to that in 2008?
Provide a succinct answer. 1.15. What is the ratio of the Claims(annual growth as % of broad money) in Albania in 2005 to that in 2006?
Offer a terse response. 0.84. What is the ratio of the Claims(annual growth as % of broad money) of Mauritius in 2005 to that in 2006?
Ensure brevity in your answer.  0.88. What is the ratio of the Claims(annual growth as % of broad money) in Turkey in 2005 to that in 2006?
Offer a very short reply. 1.24. What is the ratio of the Claims(annual growth as % of broad money) of Uruguay in 2005 to that in 2006?
Your answer should be compact. 0.03. What is the ratio of the Claims(annual growth as % of broad money) in Albania in 2005 to that in 2007?
Keep it short and to the point. 0.74. What is the ratio of the Claims(annual growth as % of broad money) in Mauritius in 2005 to that in 2007?
Make the answer very short. 0.44. What is the ratio of the Claims(annual growth as % of broad money) of Turkey in 2005 to that in 2007?
Your answer should be very brief. 1.53. What is the ratio of the Claims(annual growth as % of broad money) in Uruguay in 2005 to that in 2007?
Your response must be concise. 0.03. What is the ratio of the Claims(annual growth as % of broad money) of Albania in 2005 to that in 2008?
Keep it short and to the point. 0.85. What is the ratio of the Claims(annual growth as % of broad money) in Mauritius in 2005 to that in 2008?
Provide a short and direct response. 0.31. What is the ratio of the Claims(annual growth as % of broad money) of Turkey in 2005 to that in 2008?
Your answer should be very brief. 1.49. What is the ratio of the Claims(annual growth as % of broad money) in Uruguay in 2005 to that in 2008?
Make the answer very short. 0.01. What is the ratio of the Claims(annual growth as % of broad money) of Albania in 2006 to that in 2007?
Offer a terse response. 0.88. What is the ratio of the Claims(annual growth as % of broad money) in Mauritius in 2006 to that in 2007?
Offer a very short reply. 0.49. What is the ratio of the Claims(annual growth as % of broad money) in Turkey in 2006 to that in 2007?
Make the answer very short. 1.23. What is the ratio of the Claims(annual growth as % of broad money) in Uruguay in 2006 to that in 2007?
Keep it short and to the point. 1.23. What is the ratio of the Claims(annual growth as % of broad money) in Albania in 2006 to that in 2008?
Make the answer very short. 1.01. What is the ratio of the Claims(annual growth as % of broad money) of Mauritius in 2006 to that in 2008?
Your answer should be very brief. 0.35. What is the ratio of the Claims(annual growth as % of broad money) in Turkey in 2006 to that in 2008?
Your answer should be very brief. 1.21. What is the ratio of the Claims(annual growth as % of broad money) of Uruguay in 2006 to that in 2008?
Offer a very short reply. 0.41. What is the ratio of the Claims(annual growth as % of broad money) of Albania in 2007 to that in 2008?
Make the answer very short. 1.15. What is the ratio of the Claims(annual growth as % of broad money) of Mauritius in 2007 to that in 2008?
Your answer should be very brief. 0.7. What is the ratio of the Claims(annual growth as % of broad money) of Turkey in 2007 to that in 2008?
Make the answer very short. 0.98. What is the ratio of the Claims(annual growth as % of broad money) in Uruguay in 2007 to that in 2008?
Give a very brief answer. 0.34. What is the difference between the highest and the second highest Claims(annual growth as % of broad money) in Albania?
Offer a terse response. 1.75. What is the difference between the highest and the second highest Claims(annual growth as % of broad money) in Mauritius?
Your answer should be very brief. 5.24. What is the difference between the highest and the second highest Claims(annual growth as % of broad money) of Turkey?
Offer a very short reply. 4.78. What is the difference between the highest and the second highest Claims(annual growth as % of broad money) of Uruguay?
Provide a short and direct response. 17.76. What is the difference between the highest and the lowest Claims(annual growth as % of broad money) of Albania?
Give a very brief answer. 12.87. What is the difference between the highest and the lowest Claims(annual growth as % of broad money) in Mauritius?
Your answer should be very brief. 19.56. What is the difference between the highest and the lowest Claims(annual growth as % of broad money) in Turkey?
Provide a short and direct response. 13.8. What is the difference between the highest and the lowest Claims(annual growth as % of broad money) of Uruguay?
Offer a terse response. 39.5. 